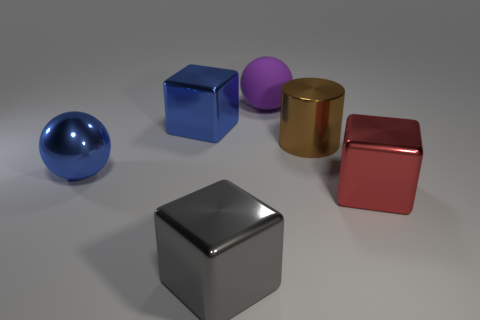What is the shape of the big red object?
Provide a short and direct response. Cube. Is the material of the large ball that is behind the blue sphere the same as the brown thing?
Offer a terse response. No. How big is the block that is in front of the cube on the right side of the purple thing?
Give a very brief answer. Large. There is a object that is both behind the cylinder and in front of the large purple matte ball; what color is it?
Offer a terse response. Blue. There is a blue ball that is the same size as the red cube; what material is it?
Your response must be concise. Metal. What number of other objects are there of the same material as the big blue sphere?
Your answer should be compact. 4. There is a large sphere to the left of the blue cube; is it the same color as the metallic block that is behind the brown metal cylinder?
Give a very brief answer. Yes. The blue thing left of the blue metallic object that is behind the big metallic cylinder is what shape?
Keep it short and to the point. Sphere. How many other things are there of the same color as the large cylinder?
Make the answer very short. 0. Is the big sphere that is in front of the brown thing made of the same material as the big ball that is on the right side of the metal ball?
Your response must be concise. No. 